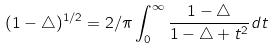<formula> <loc_0><loc_0><loc_500><loc_500>( 1 - \triangle ) ^ { 1 / 2 } = 2 / \pi \int _ { 0 } ^ { \infty } \frac { 1 - \triangle } { 1 - \triangle + t ^ { 2 } } d t</formula> 